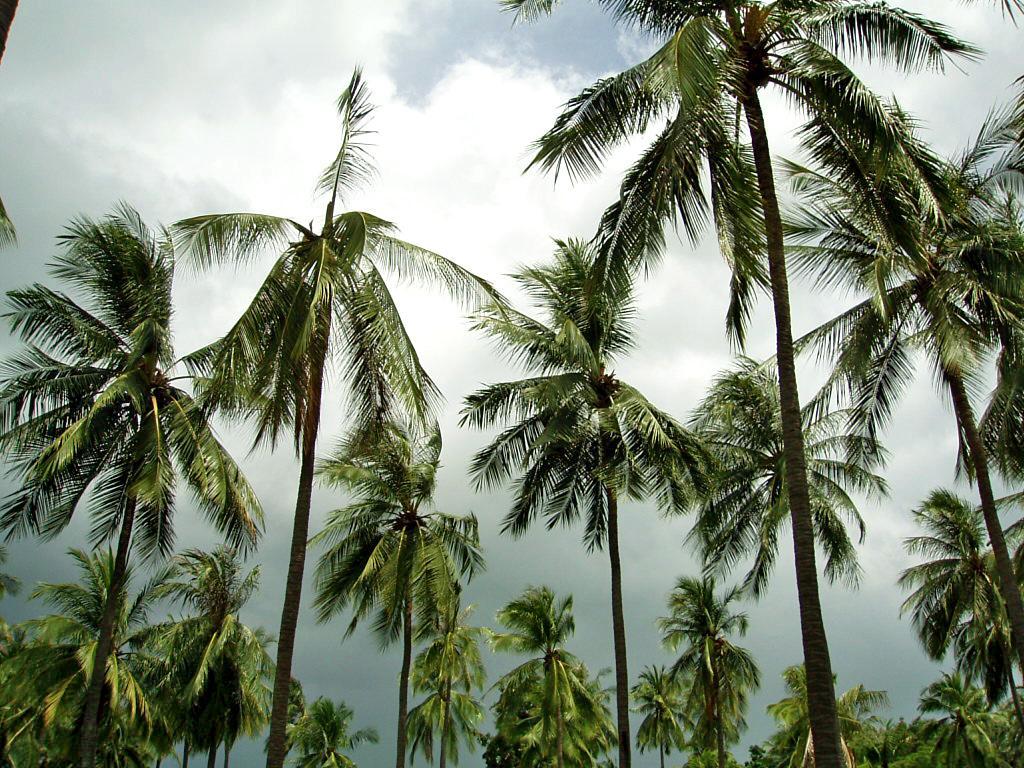Can you describe this image briefly? In this image I can see few trees in green color. In the background the sky is in white and blue color. 